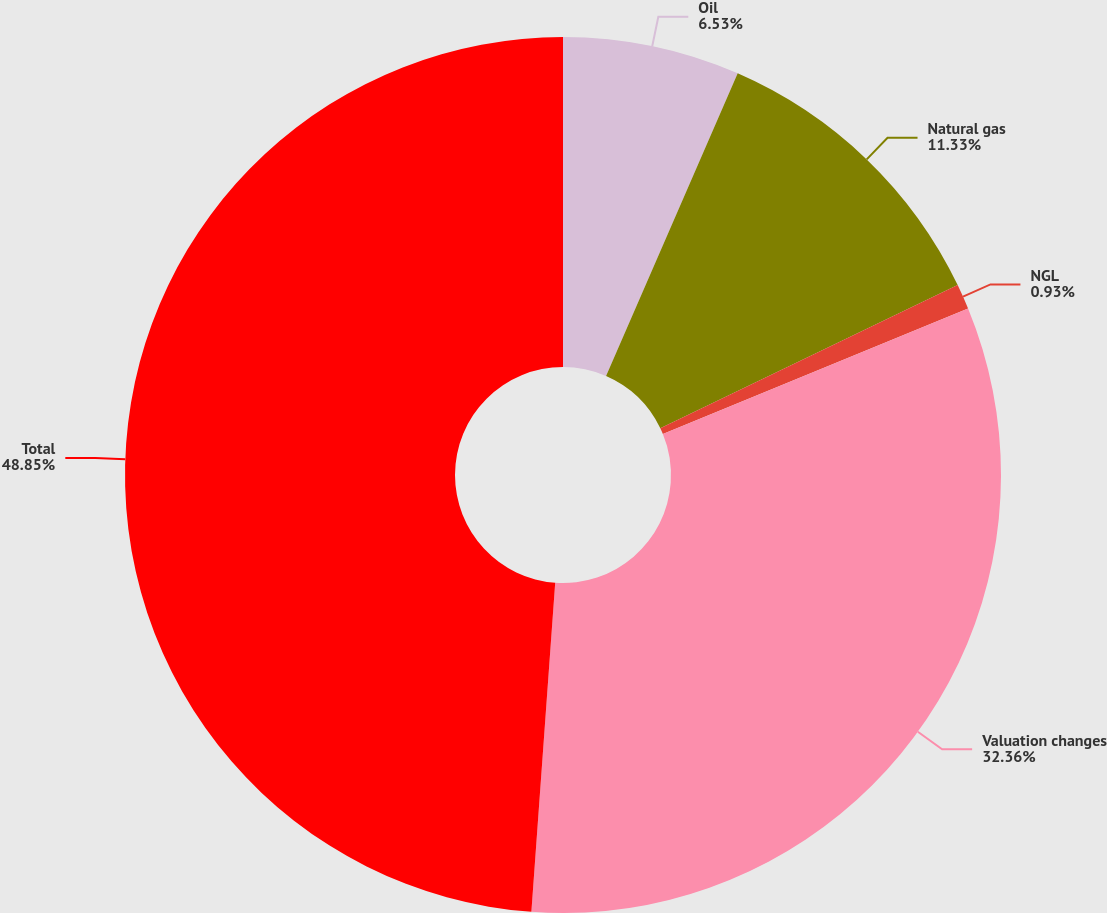<chart> <loc_0><loc_0><loc_500><loc_500><pie_chart><fcel>Oil<fcel>Natural gas<fcel>NGL<fcel>Valuation changes<fcel>Total<nl><fcel>6.53%<fcel>11.33%<fcel>0.93%<fcel>32.36%<fcel>48.85%<nl></chart> 